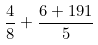Convert formula to latex. <formula><loc_0><loc_0><loc_500><loc_500>\frac { 4 } { 8 } + \frac { 6 + 1 9 1 } { 5 }</formula> 